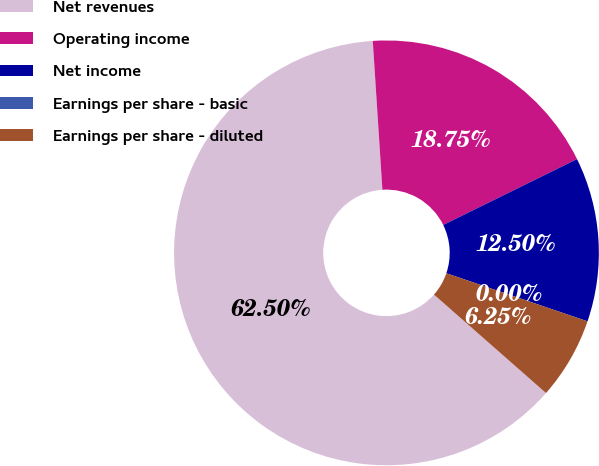Convert chart to OTSL. <chart><loc_0><loc_0><loc_500><loc_500><pie_chart><fcel>Net revenues<fcel>Operating income<fcel>Net income<fcel>Earnings per share - basic<fcel>Earnings per share - diluted<nl><fcel>62.5%<fcel>18.75%<fcel>12.5%<fcel>0.0%<fcel>6.25%<nl></chart> 